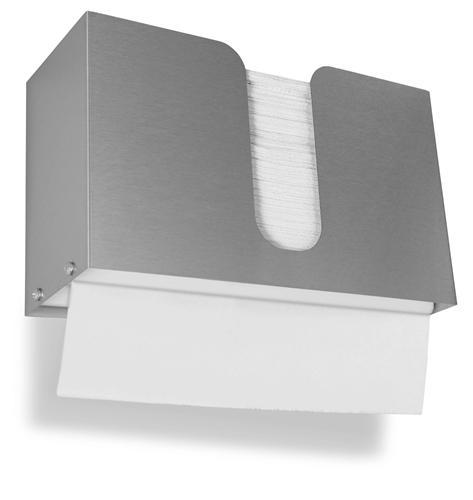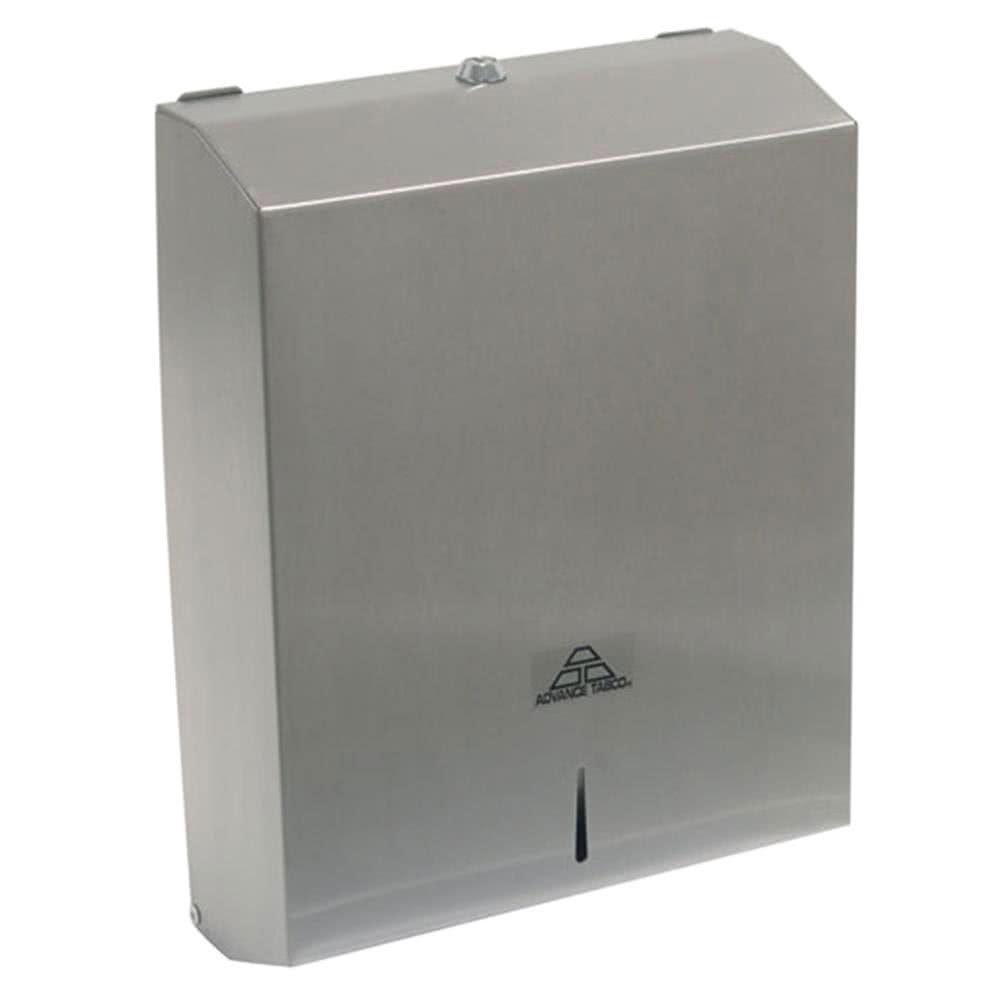The first image is the image on the left, the second image is the image on the right. Assess this claim about the two images: "At least one image shows exactly one clear rectangular tray-like container of folded paper towels.". Correct or not? Answer yes or no. No. The first image is the image on the left, the second image is the image on the right. Assess this claim about the two images: "There is not paper visible in the grey dispenser in the right.". Correct or not? Answer yes or no. Yes. 